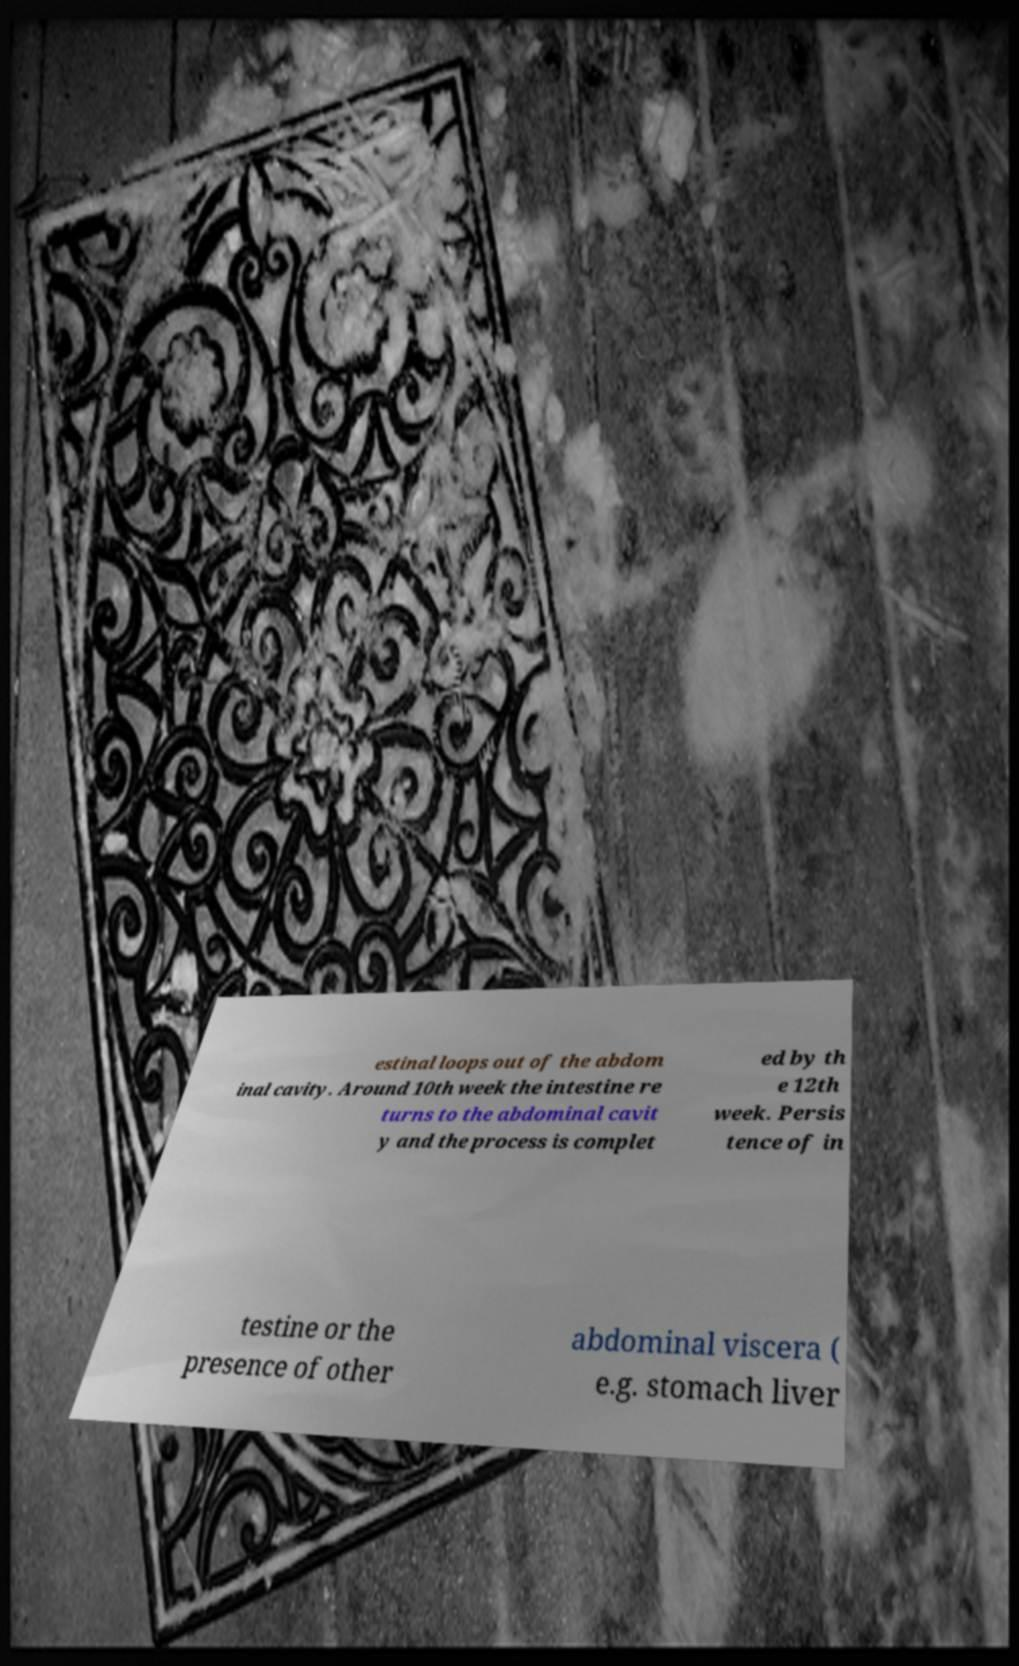What messages or text are displayed in this image? I need them in a readable, typed format. estinal loops out of the abdom inal cavity. Around 10th week the intestine re turns to the abdominal cavit y and the process is complet ed by th e 12th week. Persis tence of in testine or the presence of other abdominal viscera ( e.g. stomach liver 